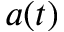Convert formula to latex. <formula><loc_0><loc_0><loc_500><loc_500>a ( t )</formula> 